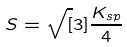<formula> <loc_0><loc_0><loc_500><loc_500>S = \sqrt { [ } 3 ] { \frac { K _ { s p } } { 4 } }</formula> 